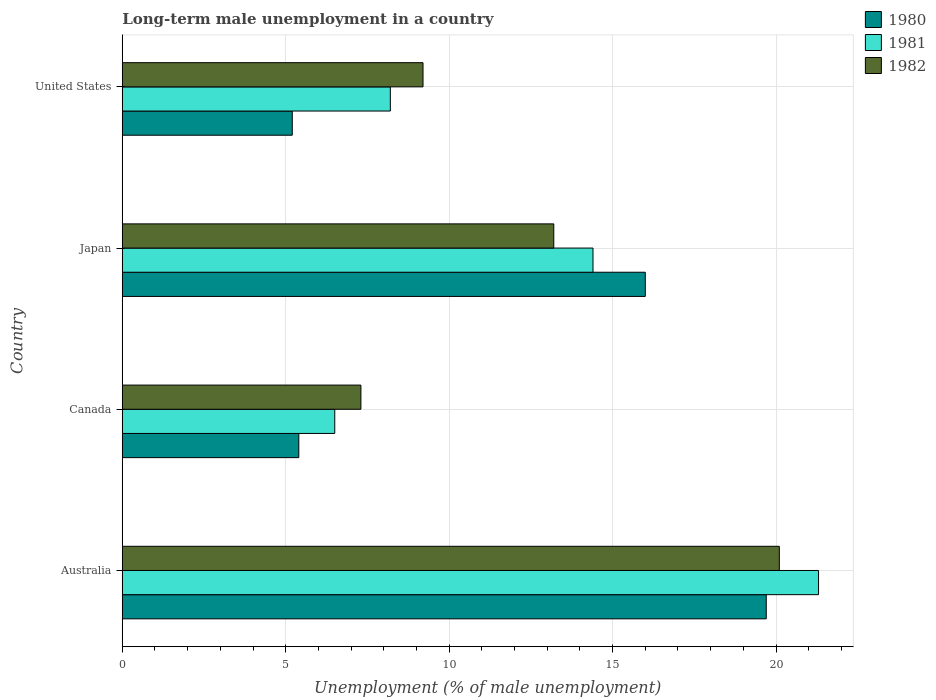How many groups of bars are there?
Give a very brief answer. 4. Are the number of bars per tick equal to the number of legend labels?
Keep it short and to the point. Yes. Are the number of bars on each tick of the Y-axis equal?
Offer a terse response. Yes. In how many cases, is the number of bars for a given country not equal to the number of legend labels?
Make the answer very short. 0. What is the percentage of long-term unemployed male population in 1982 in United States?
Your response must be concise. 9.2. Across all countries, what is the maximum percentage of long-term unemployed male population in 1982?
Your answer should be very brief. 20.1. Across all countries, what is the minimum percentage of long-term unemployed male population in 1982?
Your response must be concise. 7.3. In which country was the percentage of long-term unemployed male population in 1981 minimum?
Make the answer very short. Canada. What is the total percentage of long-term unemployed male population in 1981 in the graph?
Your answer should be compact. 50.4. What is the difference between the percentage of long-term unemployed male population in 1982 in Canada and that in United States?
Keep it short and to the point. -1.9. What is the difference between the percentage of long-term unemployed male population in 1980 in Japan and the percentage of long-term unemployed male population in 1982 in Australia?
Your response must be concise. -4.1. What is the average percentage of long-term unemployed male population in 1982 per country?
Make the answer very short. 12.45. What is the difference between the percentage of long-term unemployed male population in 1980 and percentage of long-term unemployed male population in 1981 in Australia?
Offer a very short reply. -1.6. In how many countries, is the percentage of long-term unemployed male population in 1982 greater than 2 %?
Ensure brevity in your answer.  4. What is the ratio of the percentage of long-term unemployed male population in 1982 in Australia to that in United States?
Your answer should be compact. 2.18. What is the difference between the highest and the second highest percentage of long-term unemployed male population in 1982?
Give a very brief answer. 6.9. What is the difference between the highest and the lowest percentage of long-term unemployed male population in 1982?
Keep it short and to the point. 12.8. What does the 2nd bar from the top in Japan represents?
Offer a terse response. 1981. What does the 1st bar from the bottom in Japan represents?
Ensure brevity in your answer.  1980. How many bars are there?
Give a very brief answer. 12. Are all the bars in the graph horizontal?
Provide a short and direct response. Yes. How many countries are there in the graph?
Give a very brief answer. 4. What is the difference between two consecutive major ticks on the X-axis?
Offer a terse response. 5. Where does the legend appear in the graph?
Provide a succinct answer. Top right. How many legend labels are there?
Make the answer very short. 3. What is the title of the graph?
Offer a very short reply. Long-term male unemployment in a country. Does "1960" appear as one of the legend labels in the graph?
Ensure brevity in your answer.  No. What is the label or title of the X-axis?
Provide a succinct answer. Unemployment (% of male unemployment). What is the Unemployment (% of male unemployment) of 1980 in Australia?
Make the answer very short. 19.7. What is the Unemployment (% of male unemployment) of 1981 in Australia?
Ensure brevity in your answer.  21.3. What is the Unemployment (% of male unemployment) of 1982 in Australia?
Your response must be concise. 20.1. What is the Unemployment (% of male unemployment) in 1980 in Canada?
Offer a very short reply. 5.4. What is the Unemployment (% of male unemployment) in 1982 in Canada?
Keep it short and to the point. 7.3. What is the Unemployment (% of male unemployment) in 1980 in Japan?
Make the answer very short. 16. What is the Unemployment (% of male unemployment) of 1981 in Japan?
Your answer should be very brief. 14.4. What is the Unemployment (% of male unemployment) of 1982 in Japan?
Your answer should be compact. 13.2. What is the Unemployment (% of male unemployment) of 1980 in United States?
Give a very brief answer. 5.2. What is the Unemployment (% of male unemployment) in 1981 in United States?
Provide a succinct answer. 8.2. What is the Unemployment (% of male unemployment) of 1982 in United States?
Offer a very short reply. 9.2. Across all countries, what is the maximum Unemployment (% of male unemployment) in 1980?
Your response must be concise. 19.7. Across all countries, what is the maximum Unemployment (% of male unemployment) in 1981?
Your response must be concise. 21.3. Across all countries, what is the maximum Unemployment (% of male unemployment) of 1982?
Your answer should be compact. 20.1. Across all countries, what is the minimum Unemployment (% of male unemployment) in 1980?
Offer a very short reply. 5.2. Across all countries, what is the minimum Unemployment (% of male unemployment) of 1981?
Provide a succinct answer. 6.5. Across all countries, what is the minimum Unemployment (% of male unemployment) in 1982?
Provide a succinct answer. 7.3. What is the total Unemployment (% of male unemployment) of 1980 in the graph?
Provide a succinct answer. 46.3. What is the total Unemployment (% of male unemployment) of 1981 in the graph?
Ensure brevity in your answer.  50.4. What is the total Unemployment (% of male unemployment) of 1982 in the graph?
Your answer should be very brief. 49.8. What is the difference between the Unemployment (% of male unemployment) of 1980 in Australia and that in Canada?
Your answer should be compact. 14.3. What is the difference between the Unemployment (% of male unemployment) in 1981 in Australia and that in Canada?
Your response must be concise. 14.8. What is the difference between the Unemployment (% of male unemployment) in 1980 in Australia and that in Japan?
Your answer should be compact. 3.7. What is the difference between the Unemployment (% of male unemployment) of 1981 in Australia and that in Japan?
Make the answer very short. 6.9. What is the difference between the Unemployment (% of male unemployment) of 1981 in Australia and that in United States?
Your response must be concise. 13.1. What is the difference between the Unemployment (% of male unemployment) of 1980 in Canada and that in Japan?
Your response must be concise. -10.6. What is the difference between the Unemployment (% of male unemployment) of 1982 in Canada and that in Japan?
Give a very brief answer. -5.9. What is the difference between the Unemployment (% of male unemployment) in 1980 in Canada and that in United States?
Keep it short and to the point. 0.2. What is the difference between the Unemployment (% of male unemployment) in 1982 in Canada and that in United States?
Keep it short and to the point. -1.9. What is the difference between the Unemployment (% of male unemployment) in 1980 in Japan and that in United States?
Your answer should be compact. 10.8. What is the difference between the Unemployment (% of male unemployment) of 1981 in Japan and that in United States?
Ensure brevity in your answer.  6.2. What is the difference between the Unemployment (% of male unemployment) of 1980 in Australia and the Unemployment (% of male unemployment) of 1982 in Canada?
Keep it short and to the point. 12.4. What is the difference between the Unemployment (% of male unemployment) in 1981 in Australia and the Unemployment (% of male unemployment) in 1982 in Canada?
Make the answer very short. 14. What is the difference between the Unemployment (% of male unemployment) in 1980 in Australia and the Unemployment (% of male unemployment) in 1981 in United States?
Your response must be concise. 11.5. What is the difference between the Unemployment (% of male unemployment) of 1980 in Australia and the Unemployment (% of male unemployment) of 1982 in United States?
Keep it short and to the point. 10.5. What is the difference between the Unemployment (% of male unemployment) of 1981 in Australia and the Unemployment (% of male unemployment) of 1982 in United States?
Your answer should be compact. 12.1. What is the difference between the Unemployment (% of male unemployment) of 1980 in Canada and the Unemployment (% of male unemployment) of 1981 in Japan?
Keep it short and to the point. -9. What is the difference between the Unemployment (% of male unemployment) of 1980 in Canada and the Unemployment (% of male unemployment) of 1982 in Japan?
Give a very brief answer. -7.8. What is the difference between the Unemployment (% of male unemployment) of 1981 in Canada and the Unemployment (% of male unemployment) of 1982 in Japan?
Your answer should be compact. -6.7. What is the difference between the Unemployment (% of male unemployment) of 1980 in Canada and the Unemployment (% of male unemployment) of 1981 in United States?
Give a very brief answer. -2.8. What is the difference between the Unemployment (% of male unemployment) in 1980 in Canada and the Unemployment (% of male unemployment) in 1982 in United States?
Offer a very short reply. -3.8. What is the difference between the Unemployment (% of male unemployment) in 1980 in Japan and the Unemployment (% of male unemployment) in 1981 in United States?
Your response must be concise. 7.8. What is the average Unemployment (% of male unemployment) in 1980 per country?
Give a very brief answer. 11.57. What is the average Unemployment (% of male unemployment) in 1982 per country?
Offer a very short reply. 12.45. What is the difference between the Unemployment (% of male unemployment) of 1981 and Unemployment (% of male unemployment) of 1982 in Australia?
Ensure brevity in your answer.  1.2. What is the difference between the Unemployment (% of male unemployment) in 1980 and Unemployment (% of male unemployment) in 1981 in Canada?
Provide a short and direct response. -1.1. What is the difference between the Unemployment (% of male unemployment) in 1981 and Unemployment (% of male unemployment) in 1982 in Canada?
Offer a terse response. -0.8. What is the difference between the Unemployment (% of male unemployment) in 1981 and Unemployment (% of male unemployment) in 1982 in Japan?
Your answer should be compact. 1.2. What is the difference between the Unemployment (% of male unemployment) of 1981 and Unemployment (% of male unemployment) of 1982 in United States?
Keep it short and to the point. -1. What is the ratio of the Unemployment (% of male unemployment) of 1980 in Australia to that in Canada?
Your response must be concise. 3.65. What is the ratio of the Unemployment (% of male unemployment) in 1981 in Australia to that in Canada?
Provide a short and direct response. 3.28. What is the ratio of the Unemployment (% of male unemployment) in 1982 in Australia to that in Canada?
Give a very brief answer. 2.75. What is the ratio of the Unemployment (% of male unemployment) in 1980 in Australia to that in Japan?
Provide a short and direct response. 1.23. What is the ratio of the Unemployment (% of male unemployment) in 1981 in Australia to that in Japan?
Give a very brief answer. 1.48. What is the ratio of the Unemployment (% of male unemployment) in 1982 in Australia to that in Japan?
Keep it short and to the point. 1.52. What is the ratio of the Unemployment (% of male unemployment) in 1980 in Australia to that in United States?
Offer a very short reply. 3.79. What is the ratio of the Unemployment (% of male unemployment) in 1981 in Australia to that in United States?
Provide a short and direct response. 2.6. What is the ratio of the Unemployment (% of male unemployment) of 1982 in Australia to that in United States?
Give a very brief answer. 2.18. What is the ratio of the Unemployment (% of male unemployment) of 1980 in Canada to that in Japan?
Keep it short and to the point. 0.34. What is the ratio of the Unemployment (% of male unemployment) in 1981 in Canada to that in Japan?
Provide a short and direct response. 0.45. What is the ratio of the Unemployment (% of male unemployment) of 1982 in Canada to that in Japan?
Ensure brevity in your answer.  0.55. What is the ratio of the Unemployment (% of male unemployment) of 1981 in Canada to that in United States?
Keep it short and to the point. 0.79. What is the ratio of the Unemployment (% of male unemployment) of 1982 in Canada to that in United States?
Offer a terse response. 0.79. What is the ratio of the Unemployment (% of male unemployment) in 1980 in Japan to that in United States?
Offer a terse response. 3.08. What is the ratio of the Unemployment (% of male unemployment) of 1981 in Japan to that in United States?
Offer a terse response. 1.76. What is the ratio of the Unemployment (% of male unemployment) of 1982 in Japan to that in United States?
Keep it short and to the point. 1.43. What is the difference between the highest and the second highest Unemployment (% of male unemployment) of 1980?
Provide a succinct answer. 3.7. What is the difference between the highest and the lowest Unemployment (% of male unemployment) of 1980?
Ensure brevity in your answer.  14.5. What is the difference between the highest and the lowest Unemployment (% of male unemployment) in 1981?
Keep it short and to the point. 14.8. 